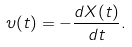Convert formula to latex. <formula><loc_0><loc_0><loc_500><loc_500>\upsilon ( t ) = - \frac { d X ( t ) } { d t } .</formula> 